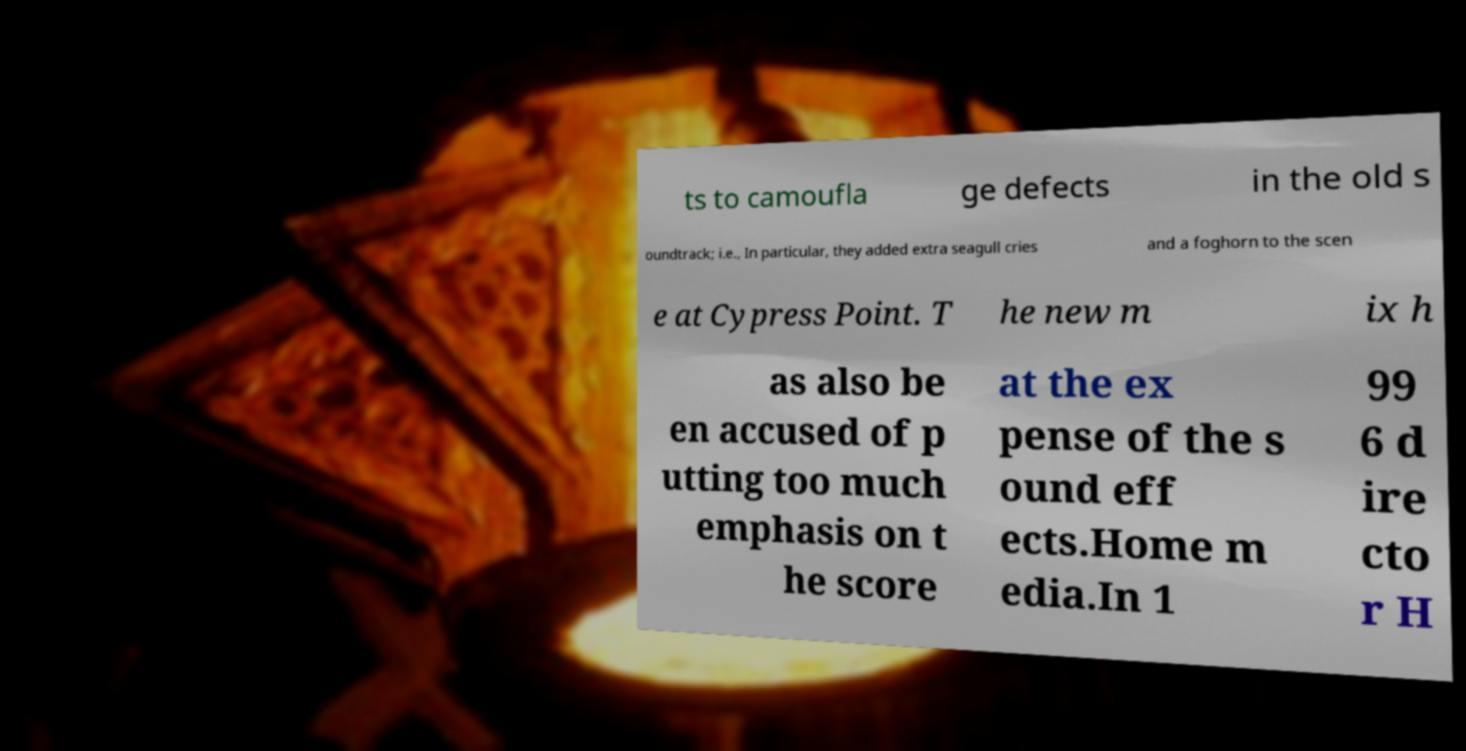Could you assist in decoding the text presented in this image and type it out clearly? ts to camoufla ge defects in the old s oundtrack; i.e., In particular, they added extra seagull cries and a foghorn to the scen e at Cypress Point. T he new m ix h as also be en accused of p utting too much emphasis on t he score at the ex pense of the s ound eff ects.Home m edia.In 1 99 6 d ire cto r H 